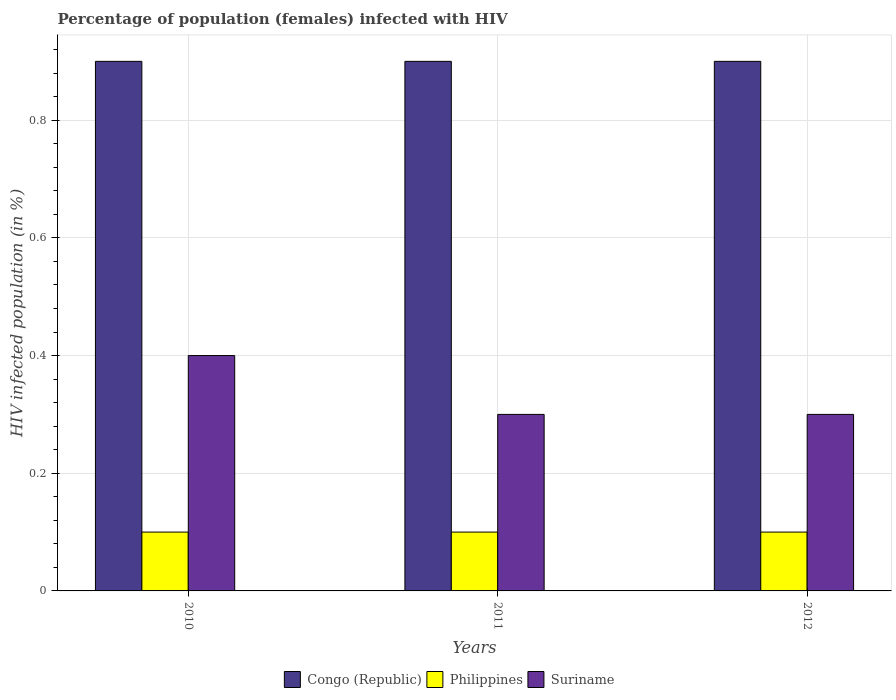How many groups of bars are there?
Your response must be concise. 3. Are the number of bars per tick equal to the number of legend labels?
Provide a short and direct response. Yes. How many bars are there on the 3rd tick from the left?
Provide a short and direct response. 3. How many bars are there on the 2nd tick from the right?
Provide a succinct answer. 3. What is the label of the 2nd group of bars from the left?
Make the answer very short. 2011. What is the percentage of HIV infected female population in Congo (Republic) in 2012?
Provide a succinct answer. 0.9. In which year was the percentage of HIV infected female population in Congo (Republic) maximum?
Provide a succinct answer. 2010. What is the difference between the percentage of HIV infected female population in Suriname in 2011 and that in 2012?
Your answer should be compact. 0. What is the difference between the percentage of HIV infected female population in Suriname in 2011 and the percentage of HIV infected female population in Congo (Republic) in 2012?
Your answer should be very brief. -0.6. In the year 2012, what is the difference between the percentage of HIV infected female population in Suriname and percentage of HIV infected female population in Congo (Republic)?
Provide a short and direct response. -0.6. In how many years, is the percentage of HIV infected female population in Suriname greater than 0.7200000000000001 %?
Your response must be concise. 0. What is the ratio of the percentage of HIV infected female population in Suriname in 2010 to that in 2012?
Make the answer very short. 1.33. What is the difference between the highest and the lowest percentage of HIV infected female population in Suriname?
Ensure brevity in your answer.  0.1. In how many years, is the percentage of HIV infected female population in Suriname greater than the average percentage of HIV infected female population in Suriname taken over all years?
Ensure brevity in your answer.  1. What does the 3rd bar from the left in 2012 represents?
Your answer should be compact. Suriname. Is it the case that in every year, the sum of the percentage of HIV infected female population in Suriname and percentage of HIV infected female population in Congo (Republic) is greater than the percentage of HIV infected female population in Philippines?
Your answer should be compact. Yes. Are all the bars in the graph horizontal?
Your response must be concise. No. What is the difference between two consecutive major ticks on the Y-axis?
Your response must be concise. 0.2. Are the values on the major ticks of Y-axis written in scientific E-notation?
Give a very brief answer. No. Does the graph contain any zero values?
Provide a short and direct response. No. How many legend labels are there?
Your response must be concise. 3. How are the legend labels stacked?
Provide a short and direct response. Horizontal. What is the title of the graph?
Offer a very short reply. Percentage of population (females) infected with HIV. What is the label or title of the Y-axis?
Ensure brevity in your answer.  HIV infected population (in %). What is the HIV infected population (in %) in Suriname in 2010?
Your answer should be very brief. 0.4. What is the HIV infected population (in %) of Congo (Republic) in 2011?
Your response must be concise. 0.9. Across all years, what is the maximum HIV infected population (in %) of Congo (Republic)?
Make the answer very short. 0.9. Across all years, what is the maximum HIV infected population (in %) in Suriname?
Give a very brief answer. 0.4. Across all years, what is the minimum HIV infected population (in %) of Congo (Republic)?
Make the answer very short. 0.9. What is the total HIV infected population (in %) in Congo (Republic) in the graph?
Keep it short and to the point. 2.7. What is the total HIV infected population (in %) in Philippines in the graph?
Make the answer very short. 0.3. What is the difference between the HIV infected population (in %) in Philippines in 2010 and that in 2011?
Offer a very short reply. 0. What is the difference between the HIV infected population (in %) in Congo (Republic) in 2010 and that in 2012?
Your response must be concise. 0. What is the difference between the HIV infected population (in %) of Congo (Republic) in 2011 and that in 2012?
Provide a short and direct response. 0. What is the difference between the HIV infected population (in %) of Philippines in 2011 and that in 2012?
Make the answer very short. 0. What is the difference between the HIV infected population (in %) in Suriname in 2011 and that in 2012?
Provide a succinct answer. 0. What is the difference between the HIV infected population (in %) of Congo (Republic) in 2010 and the HIV infected population (in %) of Suriname in 2011?
Keep it short and to the point. 0.6. What is the difference between the HIV infected population (in %) in Philippines in 2010 and the HIV infected population (in %) in Suriname in 2011?
Your response must be concise. -0.2. What is the difference between the HIV infected population (in %) of Congo (Republic) in 2010 and the HIV infected population (in %) of Philippines in 2012?
Give a very brief answer. 0.8. What is the difference between the HIV infected population (in %) of Congo (Republic) in 2010 and the HIV infected population (in %) of Suriname in 2012?
Offer a very short reply. 0.6. What is the difference between the HIV infected population (in %) in Philippines in 2010 and the HIV infected population (in %) in Suriname in 2012?
Offer a very short reply. -0.2. What is the difference between the HIV infected population (in %) of Congo (Republic) in 2011 and the HIV infected population (in %) of Philippines in 2012?
Keep it short and to the point. 0.8. What is the average HIV infected population (in %) in Philippines per year?
Provide a short and direct response. 0.1. What is the average HIV infected population (in %) in Suriname per year?
Your answer should be compact. 0.33. In the year 2010, what is the difference between the HIV infected population (in %) in Congo (Republic) and HIV infected population (in %) in Suriname?
Give a very brief answer. 0.5. In the year 2011, what is the difference between the HIV infected population (in %) of Congo (Republic) and HIV infected population (in %) of Philippines?
Offer a very short reply. 0.8. In the year 2011, what is the difference between the HIV infected population (in %) in Congo (Republic) and HIV infected population (in %) in Suriname?
Your answer should be compact. 0.6. In the year 2011, what is the difference between the HIV infected population (in %) of Philippines and HIV infected population (in %) of Suriname?
Make the answer very short. -0.2. In the year 2012, what is the difference between the HIV infected population (in %) of Congo (Republic) and HIV infected population (in %) of Philippines?
Your answer should be compact. 0.8. In the year 2012, what is the difference between the HIV infected population (in %) of Congo (Republic) and HIV infected population (in %) of Suriname?
Give a very brief answer. 0.6. What is the ratio of the HIV infected population (in %) of Congo (Republic) in 2010 to that in 2011?
Your answer should be very brief. 1. What is the ratio of the HIV infected population (in %) of Suriname in 2010 to that in 2011?
Provide a short and direct response. 1.33. What is the ratio of the HIV infected population (in %) of Congo (Republic) in 2010 to that in 2012?
Your answer should be compact. 1. What is the ratio of the HIV infected population (in %) of Philippines in 2010 to that in 2012?
Offer a very short reply. 1. What is the ratio of the HIV infected population (in %) in Congo (Republic) in 2011 to that in 2012?
Offer a terse response. 1. What is the ratio of the HIV infected population (in %) in Suriname in 2011 to that in 2012?
Give a very brief answer. 1. What is the difference between the highest and the second highest HIV infected population (in %) in Congo (Republic)?
Your response must be concise. 0. What is the difference between the highest and the second highest HIV infected population (in %) in Philippines?
Give a very brief answer. 0. What is the difference between the highest and the second highest HIV infected population (in %) in Suriname?
Provide a short and direct response. 0.1. What is the difference between the highest and the lowest HIV infected population (in %) in Congo (Republic)?
Your response must be concise. 0. What is the difference between the highest and the lowest HIV infected population (in %) of Philippines?
Ensure brevity in your answer.  0. 